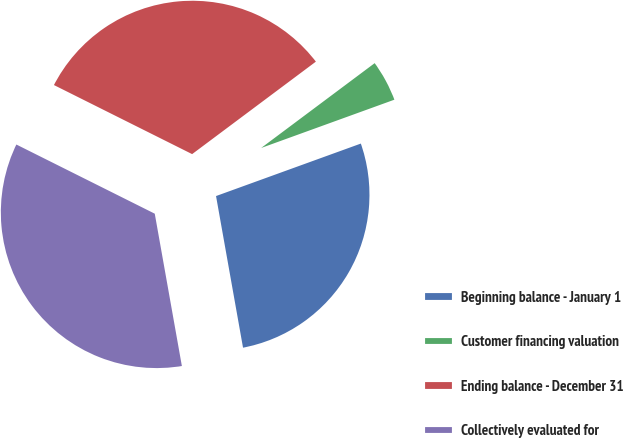<chart> <loc_0><loc_0><loc_500><loc_500><pie_chart><fcel>Beginning balance - January 1<fcel>Customer financing valuation<fcel>Ending balance - December 31<fcel>Collectively evaluated for<nl><fcel>27.73%<fcel>4.68%<fcel>32.41%<fcel>35.18%<nl></chart> 